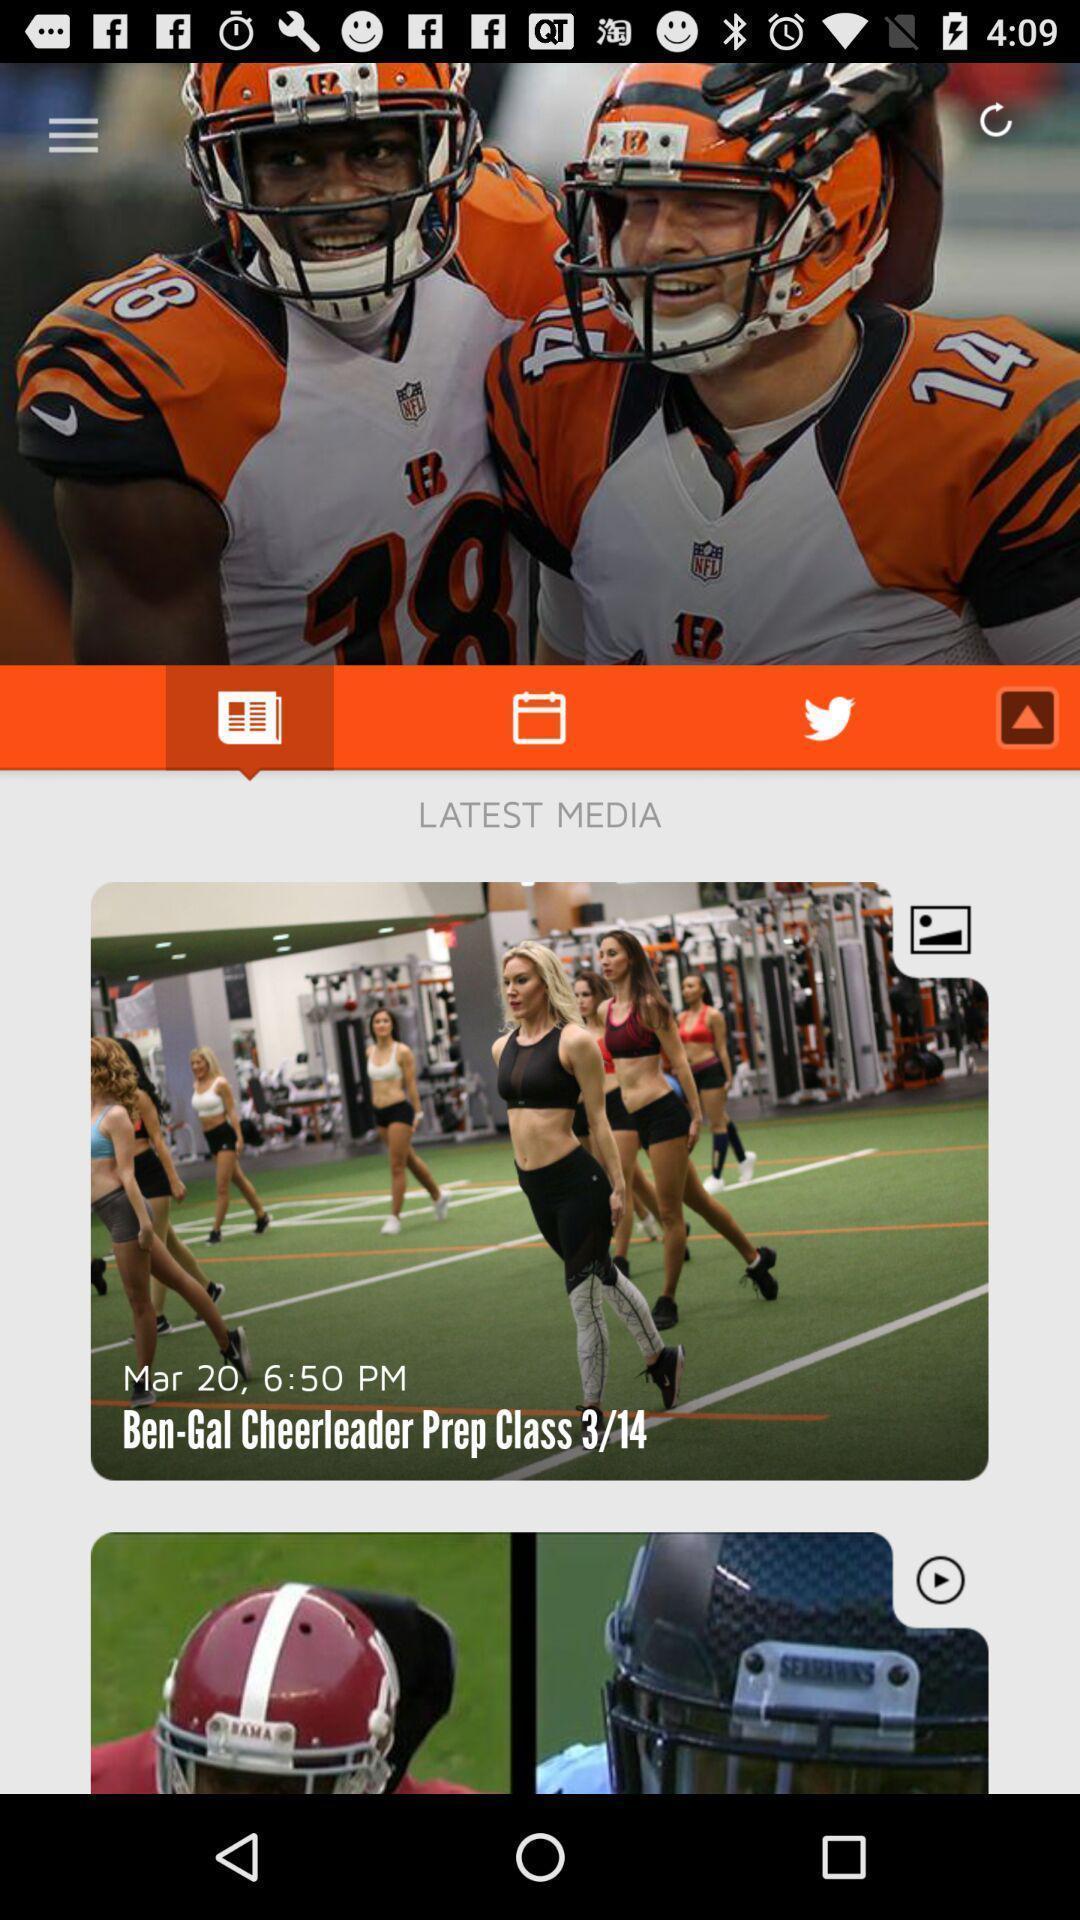What is the overall content of this screenshot? Page showing real time breaking news about sports. 